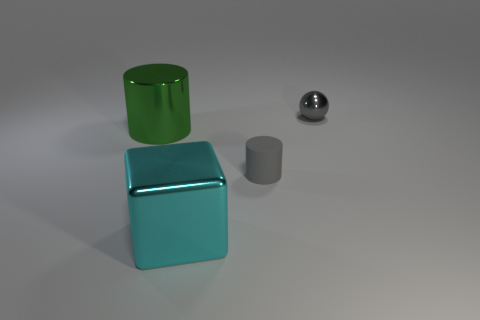How many other things are the same color as the ball?
Offer a terse response. 1. There is a object behind the metal cylinder; what is its size?
Ensure brevity in your answer.  Small. There is a tiny object behind the metal cylinder; is its color the same as the matte thing?
Your response must be concise. Yes. How many big shiny objects are the same shape as the small gray rubber thing?
Your answer should be compact. 1. What number of objects are small things behind the green shiny thing or big objects on the left side of the big metal block?
Provide a short and direct response. 2. How many red things are shiny spheres or matte cylinders?
Make the answer very short. 0. There is a object that is both left of the rubber cylinder and behind the tiny rubber object; what is its material?
Your answer should be very brief. Metal. Does the green cylinder have the same material as the gray cylinder?
Keep it short and to the point. No. What number of gray shiny objects have the same size as the gray matte cylinder?
Offer a very short reply. 1. Is the number of metallic cylinders in front of the tiny gray rubber object the same as the number of big cylinders?
Your answer should be very brief. No. 